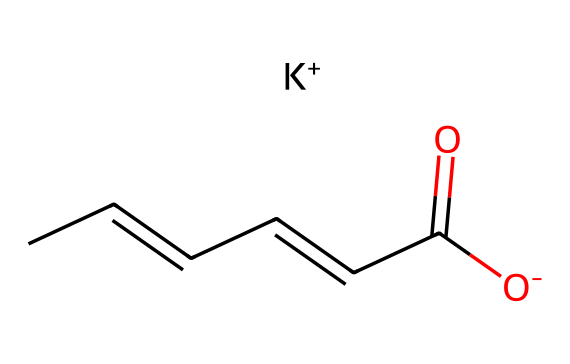What is the molecular formula of potassium sorbate? The molecular formula can be derived from its structure, which shows it consists of carbon (C), hydrogen (H), oxygen (O), and potassium (K) atoms. Counting the atoms in the SMILES representation, we find it is C6H7O2K.
Answer: C6H7O2K How many carbon atoms are present in potassium sorbate? By analyzing the SMILES representation, we can count the number of carbon atoms directly. There are six carbon atoms in the structure.
Answer: 6 What type of bond is present between the carbon atoms in potassium sorbate? The presence of the "C=C" notation in the SMILES indicates that there are double bonds between some carbon atoms, specifically in the alkene portion of the molecule.
Answer: double bond What is the charge of the potassium ion in potassium sorbate? The "K+" notation in the SMILES indicates that the potassium ion carries a positive charge. Therefore, the charge is +1.
Answer: +1 What functional group is present in potassium sorbate? The carboxylate functional group, indicative of its preservation properties, can be identified from the "C(=O)[O-]" part of the SMILES, showing a carbonyl and an oxygen atom with a negative charge.
Answer: carboxylate How does potassium sorbate contribute to food preservation? Potassium sorbate inhibits the growth of mold and yeast, thus extending the shelf life of food products. This property is reflected in its molecular structure, particularly in the functional group.
Answer: inhibits mold and yeast What role does the potassium ion play in the chemical structure? The potassium ion acts as a counterion to the negatively charged carboxylate group, balancing the overall charge in the molecule and contributing to its solubility and efficacy as a preservative.
Answer: counterion 